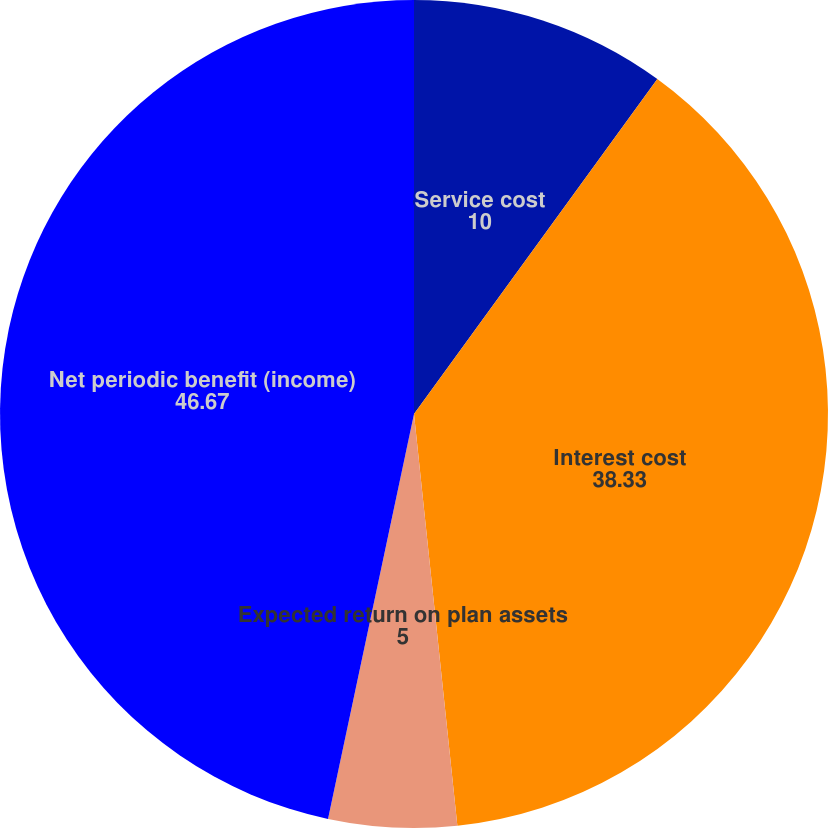Convert chart to OTSL. <chart><loc_0><loc_0><loc_500><loc_500><pie_chart><fcel>Service cost<fcel>Interest cost<fcel>Expected return on plan assets<fcel>Net periodic benefit (income)<nl><fcel>10.0%<fcel>38.33%<fcel>5.0%<fcel>46.67%<nl></chart> 